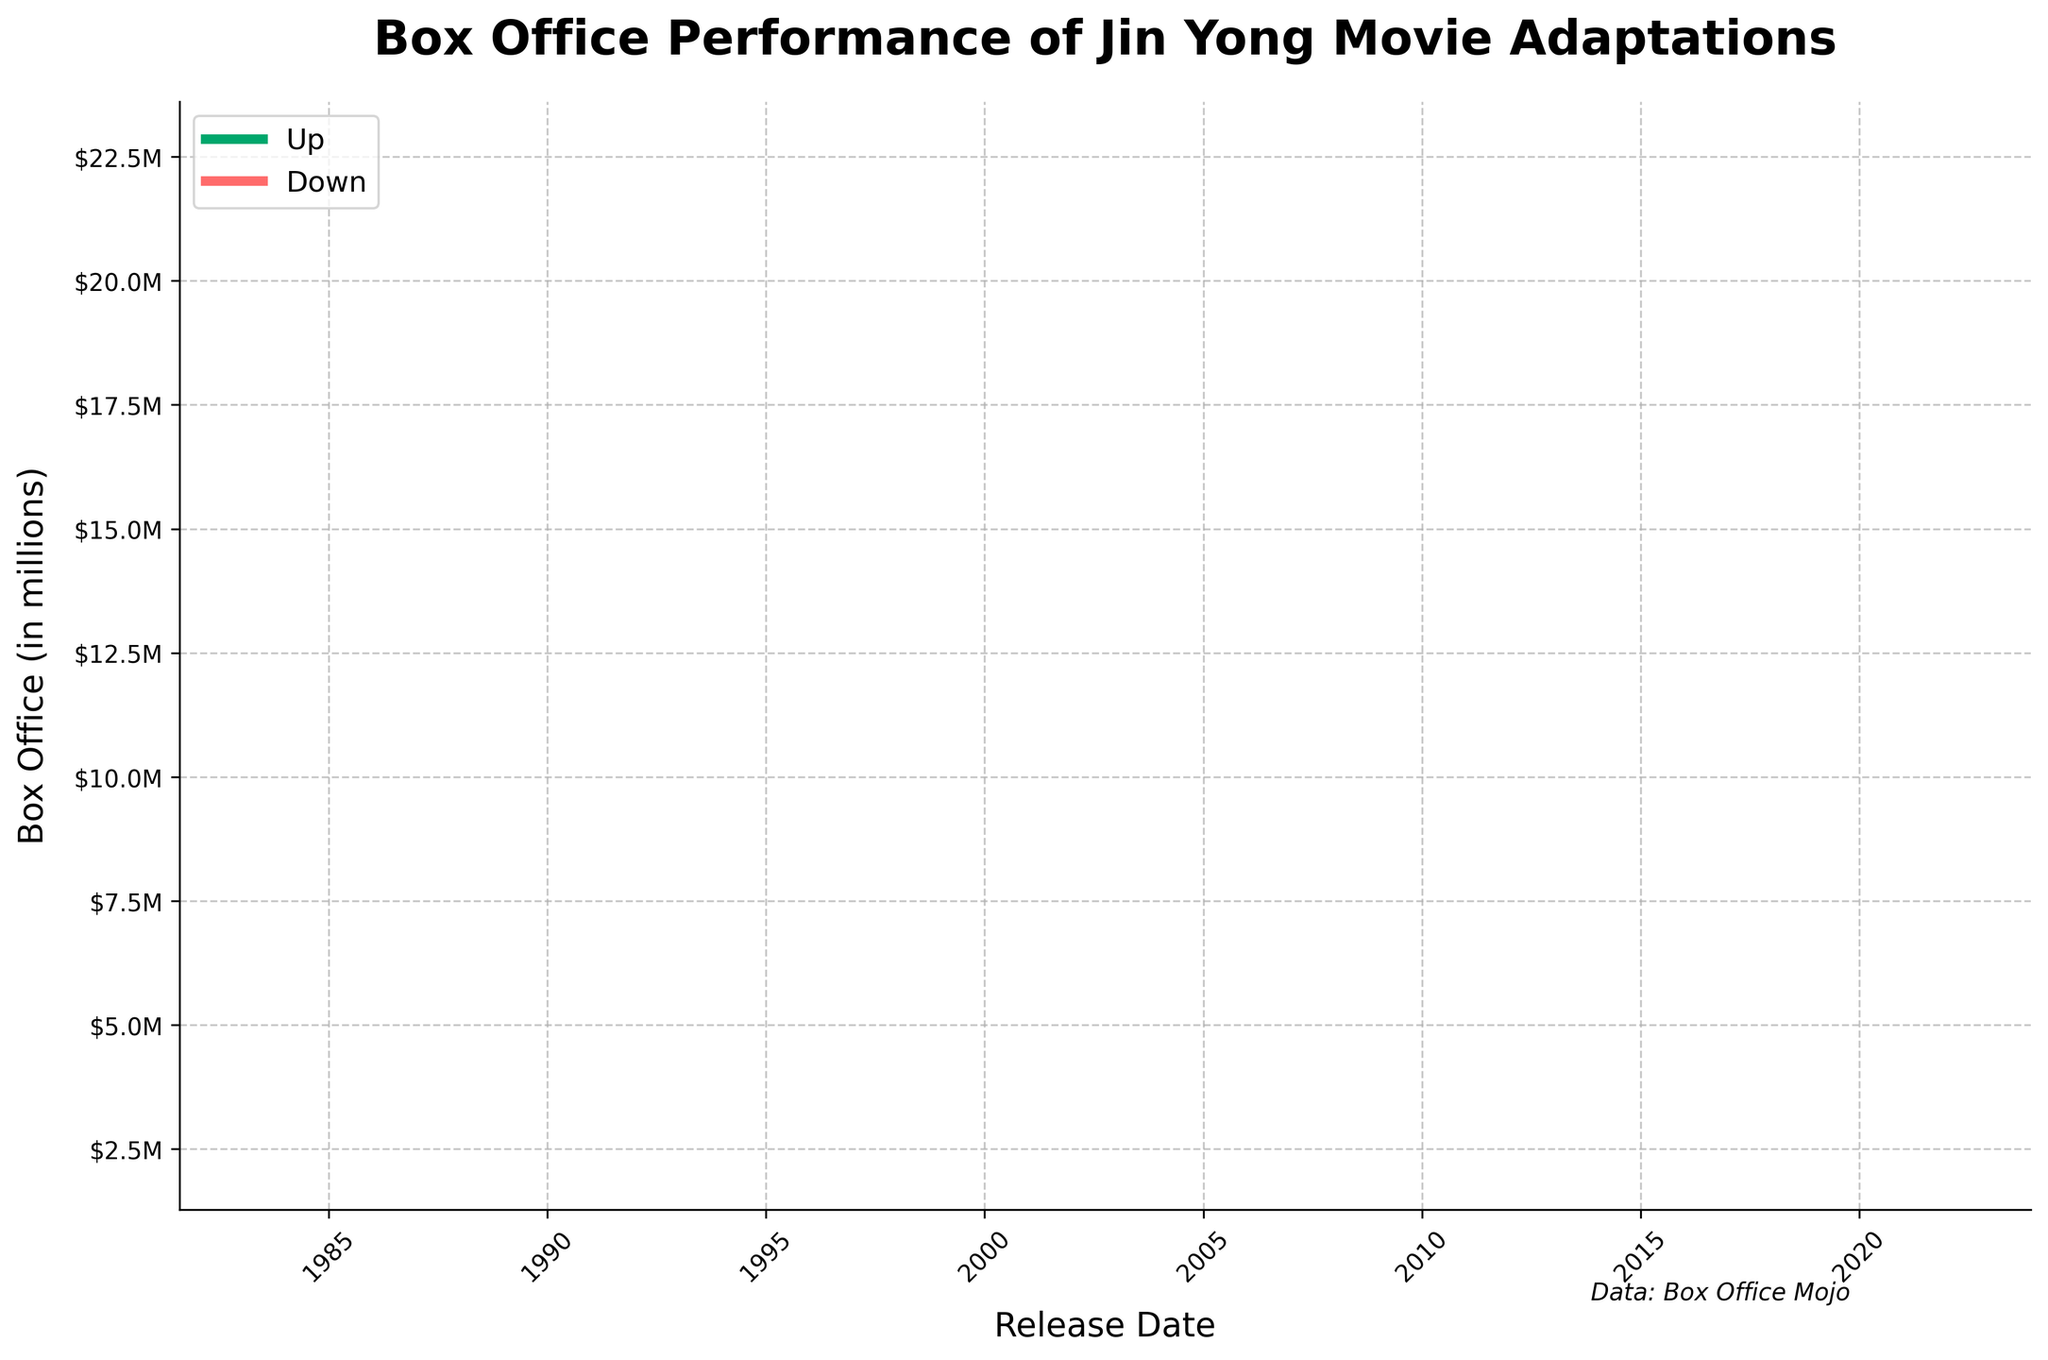Who directed the most recent Jin Yong movie adaptation in the dataset? The most recent movie adaptation mentioned in the dataset is from 2022. To find who directed it, we look at the OHLC chart and track down the specific movie released on 2022-01-01. A quick background check reveals that the 2022 adaptation is of the movie "Heaven Sword and Dragon Saber".
Answer: Gordon Chan Which movie adaptation had the highest opening box office over the opening weekend? The highest box office over the opening weekend can be identified by looking for the specific peak in the chart. From the OHLC chart, the peak corresponds to the movie released in 2022-01-01. The highest value is 22.6 million.
Answer: "Heaven Sword and Dragon Saber" (2022) Which adaptation had the lowest opening box office over the opening weekend? The lowest box office over the opening weekend can be found by identifying the lowest point in the OHLC chart. The lowest value is on 1983-07-08 with 2.3 million.
Answer: "Du Xia" (1983) How does the 2003 adaptation compare to the 2019 adaptation in terms of the closing box office? Comparing the closing prices for both years, we see that the 2003 adaptation has a closing box office of 6.5 million and the 2019 adaptation has a closing box office of 15.1 million. The 2019 adaptation has a higher closing box office.
Answer: The 2019 adaptation's closing box office is higher What is the average opening box office of movies released between 1983 and 2003? The movies within this range are from 1983 (2.5 million), 1992 (3.8 million), and 2003 (5.2 million). To get the average, sum these values and divide them by the number of movies: (2.5 + 3.8 + 5.2) / 3 = 11.5 / 3 = 3.83 million.
Answer: 3.83 million Which movie has the greatest difference between its highest and lowest box office figures? To find the movie with the greatest difference between highest and lowest figures, calculate the difference for each movie and identify the maximum. E.g., for the 2022 movie: 22.6 - 17.5 = 5.1 million. Comparing all differences, 2022 has the maximum difference (22.6 - 17.5 = 5.1).
Answer: "The Legend of the Condor Heroes" (2022) Which year had the closest opening and closing box office figures? To find this, calculate the difference between opening and closing figures for each year and identify the smallest difference. Example: For 1992, 4.2 - 3.8 = 0.4 million. The year with the smallest difference is 1992.
Answer: 1992 